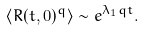Convert formula to latex. <formula><loc_0><loc_0><loc_500><loc_500>\langle R ( t , 0 ) ^ { q } \rangle \sim e ^ { \lambda _ { 1 } q t } .</formula> 